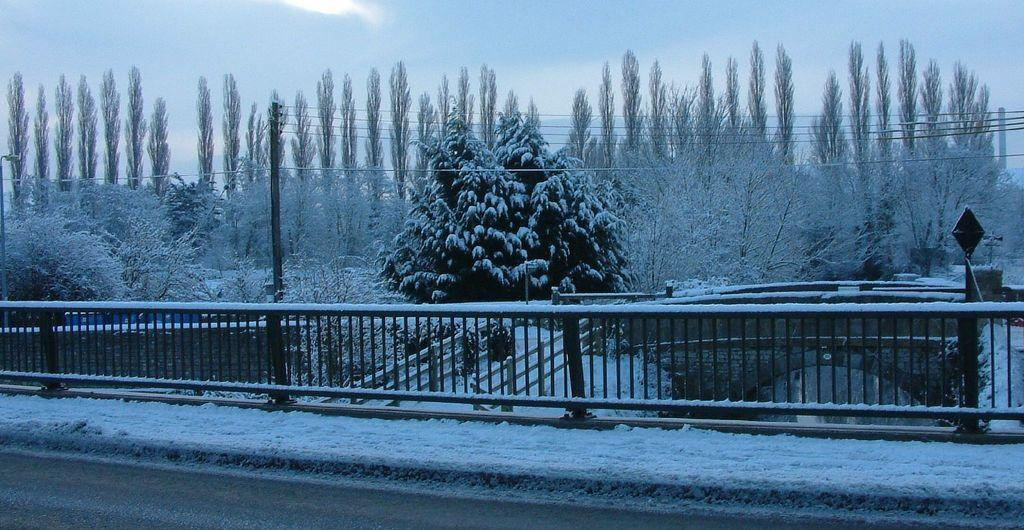What type of vegetation can be seen in the image? There are trees and plants in the image. What structures are present in the image? There are poles and a metal fence in the image. What is the weather like in the image? There is snow visible in the image, and the sky is blue and cloudy. What type of protest is taking place in the image? There is no protest present in the image; it features trees, poles, a metal fence, plants, snow, and a blue and cloudy sky. What degree of difficulty is required to print the image? The question of difficulty in printing the image is not relevant, as the image is already visible and does not need to be printed. 